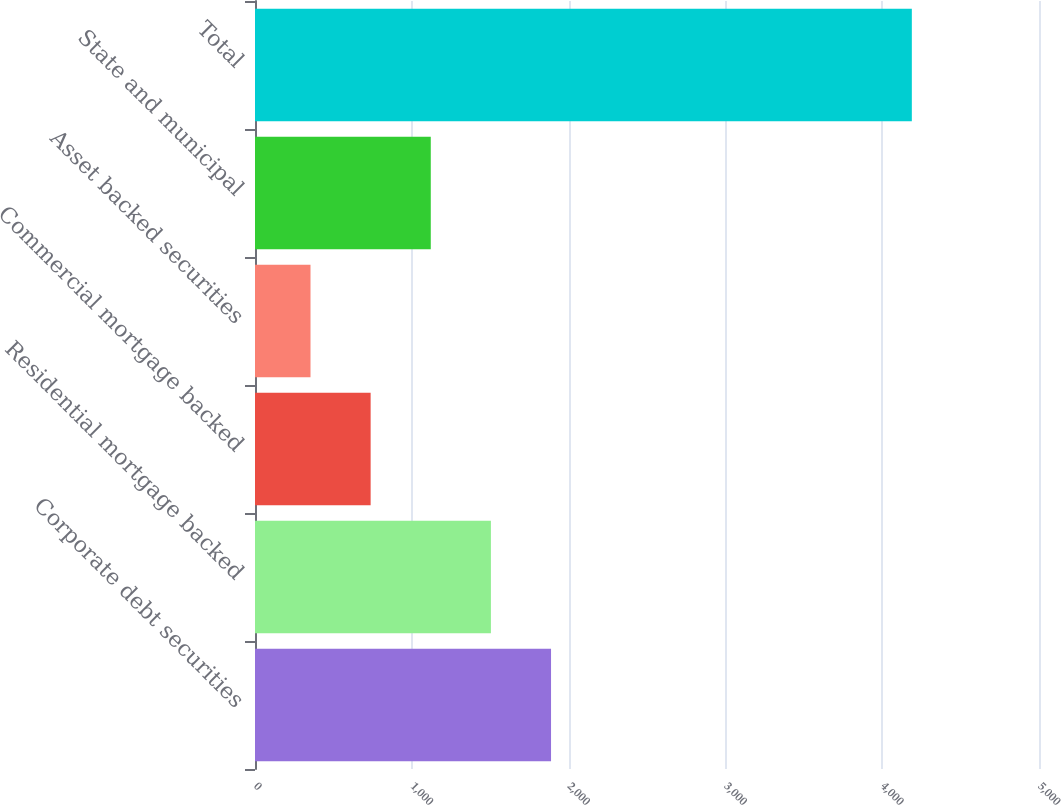Convert chart to OTSL. <chart><loc_0><loc_0><loc_500><loc_500><bar_chart><fcel>Corporate debt securities<fcel>Residential mortgage backed<fcel>Commercial mortgage backed<fcel>Asset backed securities<fcel>State and municipal<fcel>Total<nl><fcel>1888<fcel>1504.5<fcel>737.5<fcel>354<fcel>1121<fcel>4189<nl></chart> 